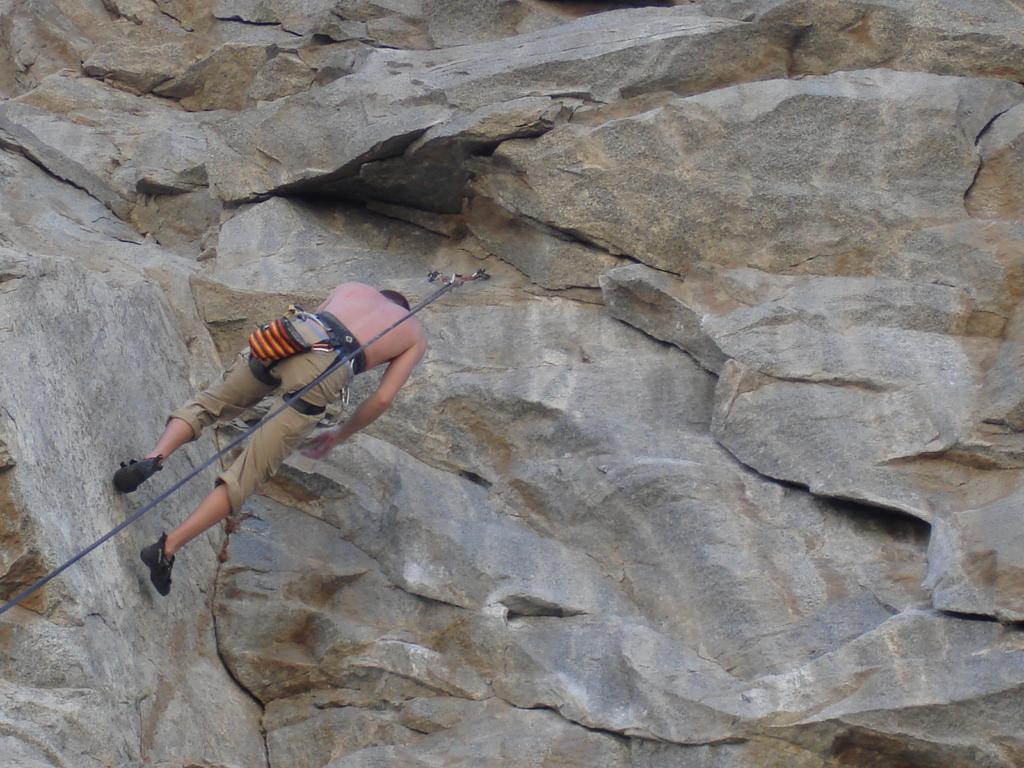Can you describe this image briefly? In this image, I can see a person on a mountain and a rope. This image taken, maybe during day. 